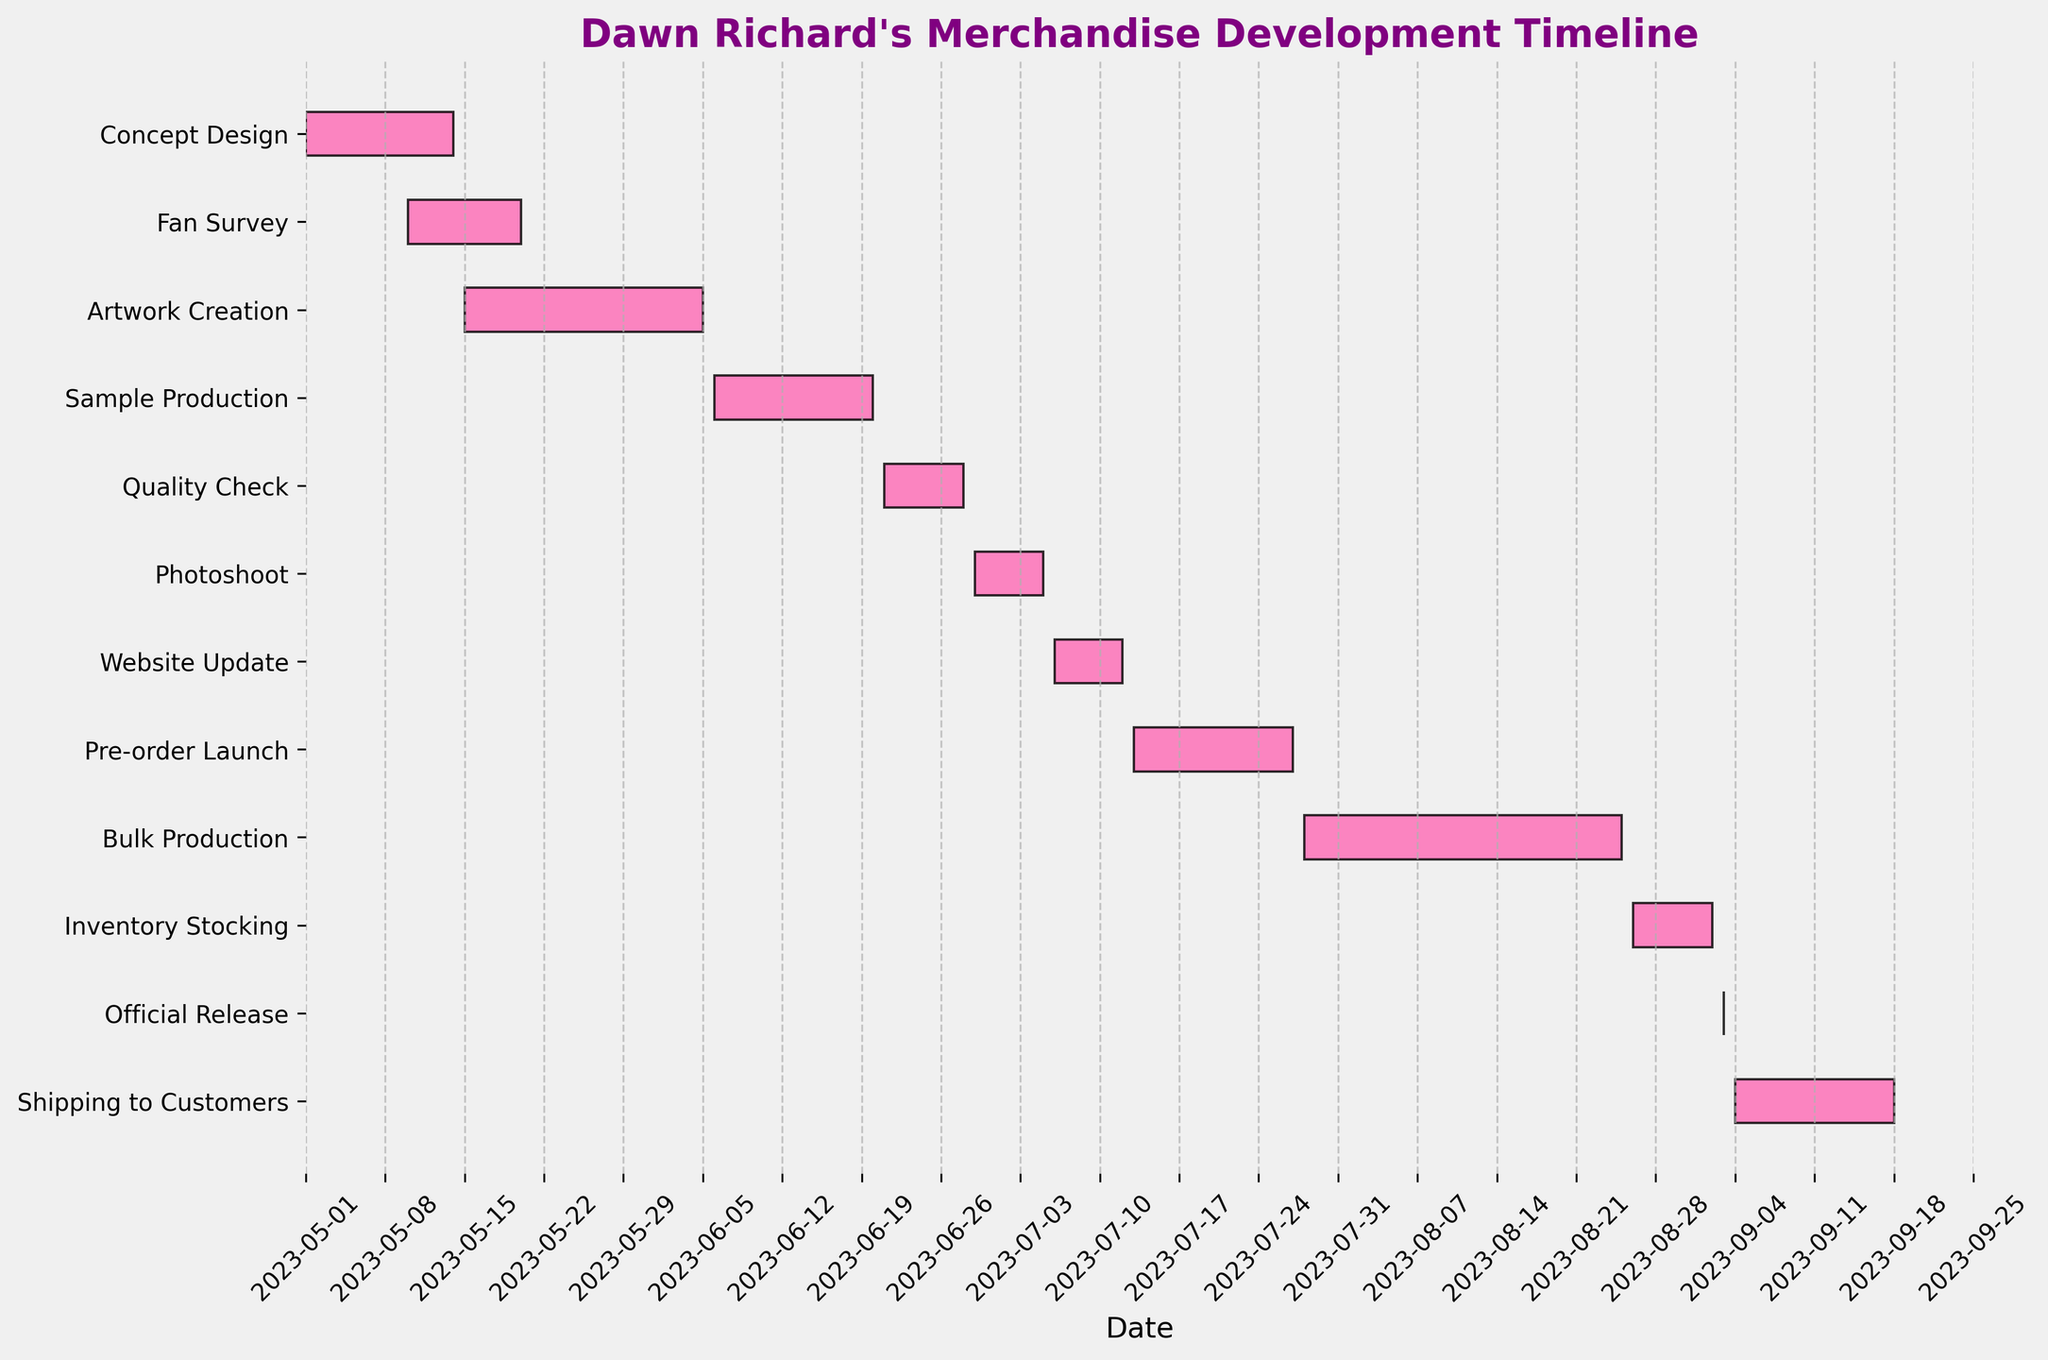What's the title of the figure? The title is displayed at the top of the Gantt chart, typically in a larger font size and bold. Here, it reads "Dawn Richard's Merchandise Development Timeline".
Answer: Dawn Richard's Merchandise Development Timeline What color are the bars representing the tasks? The bars in the Gantt chart are color-coded. In this chart, all the bars are colored in a pink hue with black edges.
Answer: Pink How many tasks are listed in the development timeline? Count the number of different bars or y-axis labels that represent each task. There are 12 tasks listed from "Concept Design" to "Shipping to Customers".
Answer: 12 Which task has the shortest duration? Check the length of each bar on the Gantt chart. The shortest bar corresponds to the "Official Release" which spans only one day, September 3rd, 2023.
Answer: Official Release During which month does “Bulk Production” start? Look for the "Bulk Production" bar and see where it begins on the x-axis labeled by dates. The "Bulk Production" task begins on July 28th, 2023, which falls in the month of July.
Answer: July Which two tasks are overlapping in the month of May? Observe the timeline in May and identify tasks that have bars extending into May. Both "Concept Design" (May 1-14) and "Fan Survey" (May 10-20) overlap in May.
Answer: Concept Design and Fan Survey How many tasks are completed by the end of June? Examine the end dates of tasks. Any task that ends on or before June 30 should be counted. These are "Concept Design", "Fan Survey", and "Artwork Creation". Thus, 3 tasks are completed by the end of June.
Answer: 3 What is the total duration of "Sample Production" in days? Calculate the duration of "Sample Production" by counting the days from its start to end date. It begins on June 6th and ends on June 20th, translating to 15 days.
Answer: 15 What tasks happen consecutively without any overlap between them? Look for tasks that start only after the previous one ends. For instance, there is no overlap between "Sample Production" (June 6-20) and "Quality Check" (June 21-28), they happen consecutively.
Answer: Sample Production and Quality Check When does the task "Pre-order Launch" end? Refer to the end date on the x-axis for the "Pre-order Launch" bar. It extends to July 27th, meaning "Pre-order Launch" ends on July 27th, 2023.
Answer: July 27, 2023 